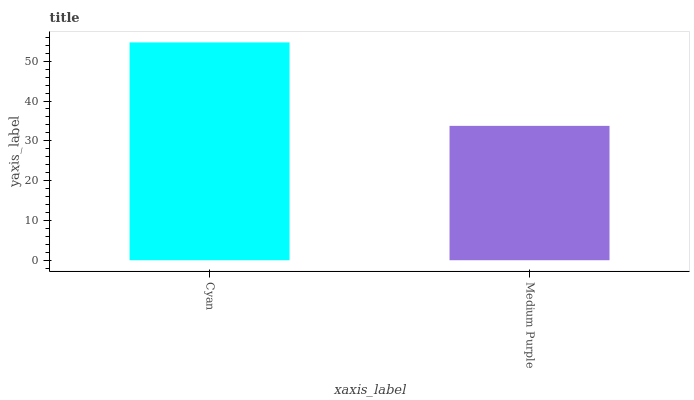Is Medium Purple the minimum?
Answer yes or no. Yes. Is Cyan the maximum?
Answer yes or no. Yes. Is Medium Purple the maximum?
Answer yes or no. No. Is Cyan greater than Medium Purple?
Answer yes or no. Yes. Is Medium Purple less than Cyan?
Answer yes or no. Yes. Is Medium Purple greater than Cyan?
Answer yes or no. No. Is Cyan less than Medium Purple?
Answer yes or no. No. Is Cyan the high median?
Answer yes or no. Yes. Is Medium Purple the low median?
Answer yes or no. Yes. Is Medium Purple the high median?
Answer yes or no. No. Is Cyan the low median?
Answer yes or no. No. 